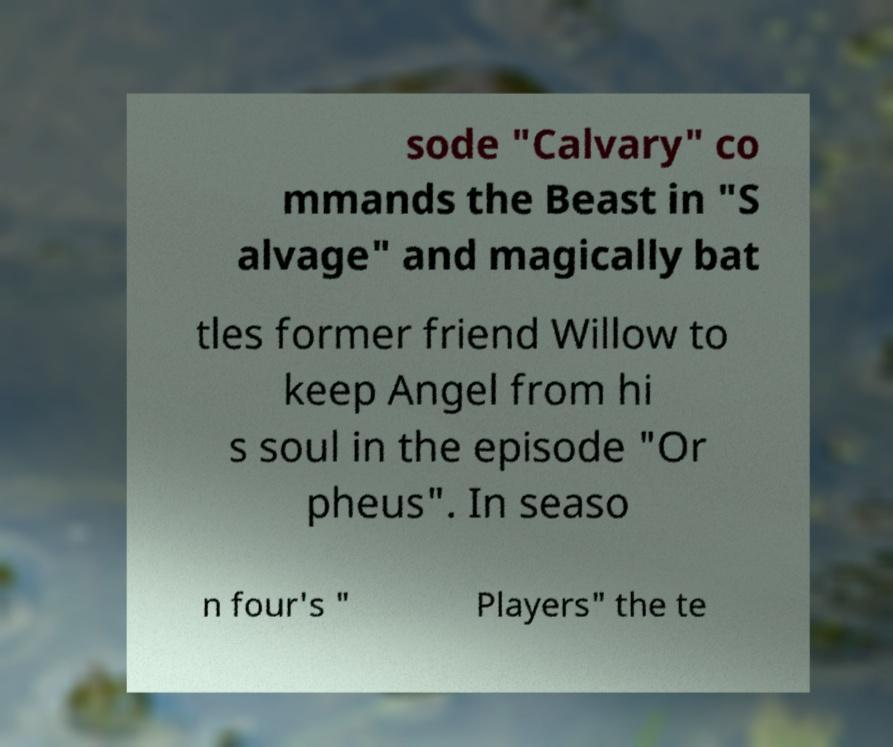Can you accurately transcribe the text from the provided image for me? sode "Calvary" co mmands the Beast in "S alvage" and magically bat tles former friend Willow to keep Angel from hi s soul in the episode "Or pheus". In seaso n four's " Players" the te 